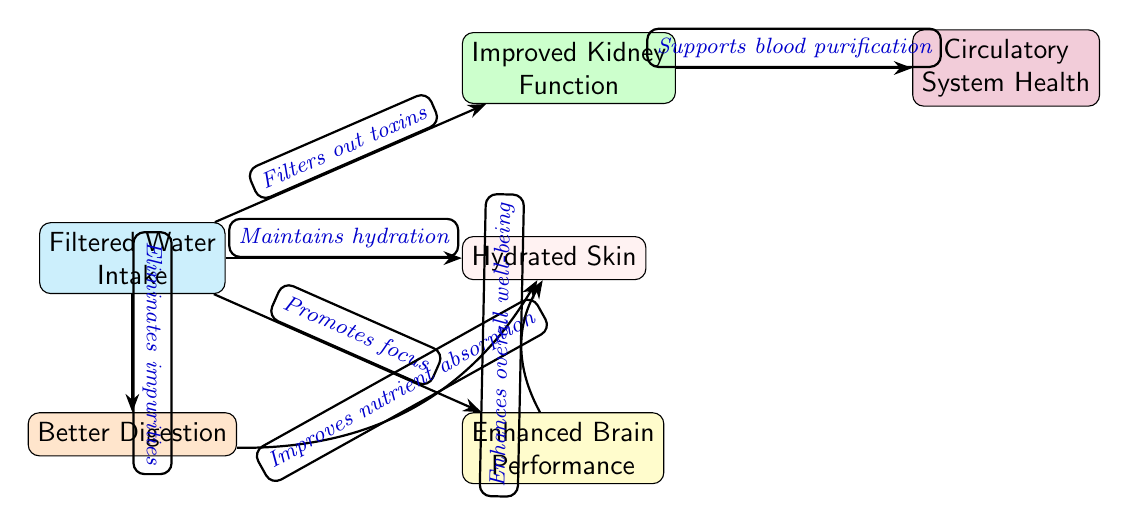What is the first step in the diagram? The diagram starts with "Filtered Water Intake," which is the first node in the food chain.
Answer: Filtered Water Intake How many nodes are there in total? The diagram contains six nodes: one for "Filtered Water Intake" and five others representing various organ system functions.
Answer: 6 What is the effect of filtered water on kidney function? The relationship shows that filtered water intake leads to "Improved Kidney Function," indicating a positive effect on kidney function.
Answer: Improved Kidney Function Which organ system health is specifically supported by filtered water after kidney function? The diagram indicates that "Circulatory System Health" is supported as a direct result of "Improved Kidney Function."
Answer: Circulatory System Health What does the edge between "Better Digestion" and "Hydrated Skin" indicate? The edge states "Improves nutrient absorption," showing that better digestion positively impacts the health of the skin through improved nutrient uptake.
Answer: Improves nutrient absorption How does filtered water influence brain performance? The diagram indicates that filtered water intake "Promotes focus," which enhances brain performance, thus establishing a direct link.
Answer: Promotes focus What is the relationship between kidney function and circulatory system health? The edge specifies that improved kidney function "Supports blood purification," contributing to greater circulatory system health.
Answer: Supports blood purification Which effect of filtered water intake directly improves skin hydration? The effect of filtered water is described as "Maintains hydration," which is the relationship that supports healthy, hydrated skin.
Answer: Maintains hydration What is the overall impact of enhanced brain performance on skin? The diagram states that enhanced brain performance "Enhances overall well-being," which indirectly supports the health of the skin, though it does not specify a direct relationship.
Answer: Enhances overall well-being 